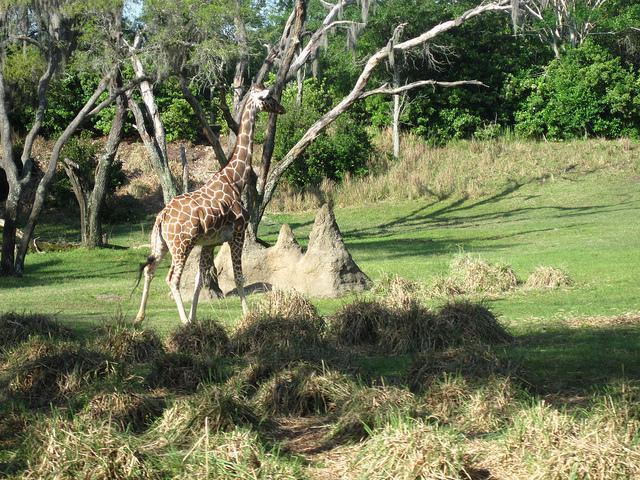How many animals are in this picture?
Give a very brief answer. 1. 